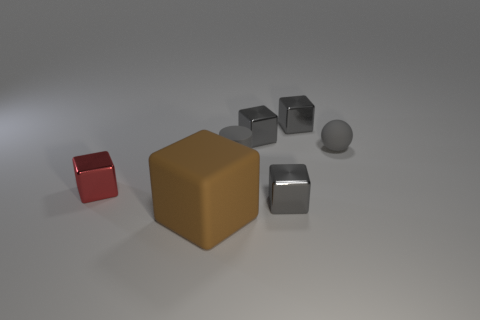There is a small sphere that is the same material as the large cube; what color is it? gray 